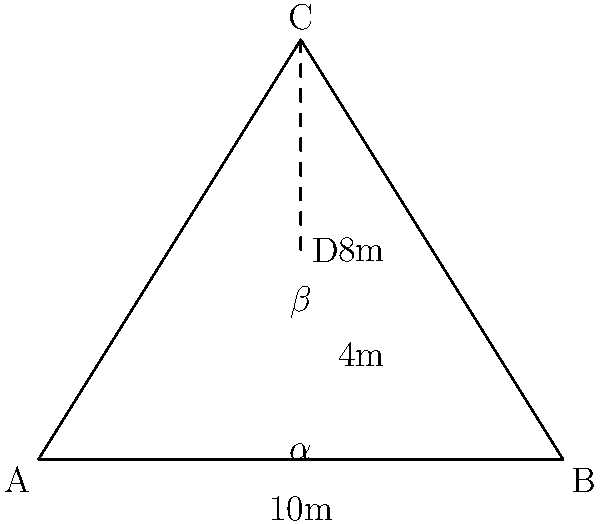In a tiered seating layout for an MMA viewing party, you're setting up screens at point C, 8 meters above the floor. The viewing area is 10 meters wide (A to B). If a spectator is seated at point D, 4 meters above the floor and centered horizontally, what is the difference between the viewing angle $\alpha$ (from the floor) and the actual viewing angle $\beta$ (from the spectator's position)? To solve this problem, we'll follow these steps:

1) First, let's calculate angle $\alpha$:
   $\tan(\alpha) = \frac{8}{5}$ (opposite / adjacent)
   $\alpha = \arctan(\frac{8}{5}) \approx 58.0°$

2) Now, let's calculate angle $\beta$:
   $\tan(\beta) = \frac{8-4}{5} = \frac{4}{5}$ (opposite / adjacent)
   $\beta = \arctan(\frac{4}{5}) \approx 38.7°$

3) The difference between these angles is:
   $\alpha - \beta = 58.0° - 38.7° \approx 19.3°$

This difference represents how much the viewing angle changes when the spectator is seated at the elevated position compared to viewing from the floor level.
Answer: $19.3°$ 